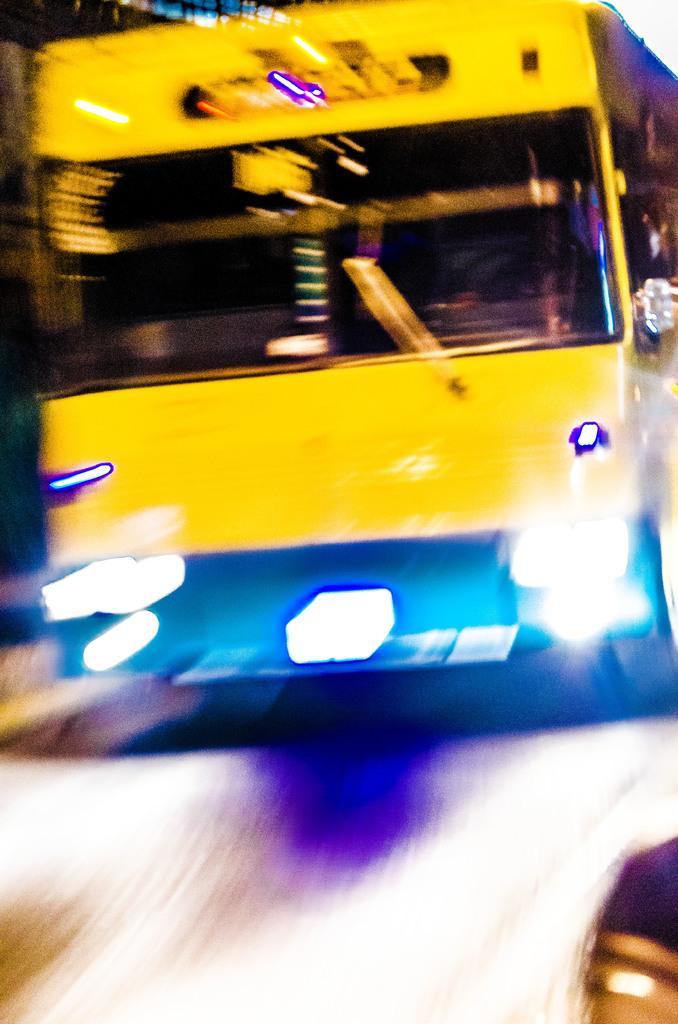Please provide a concise description of this image. In this image we can see a yellow color bus. 